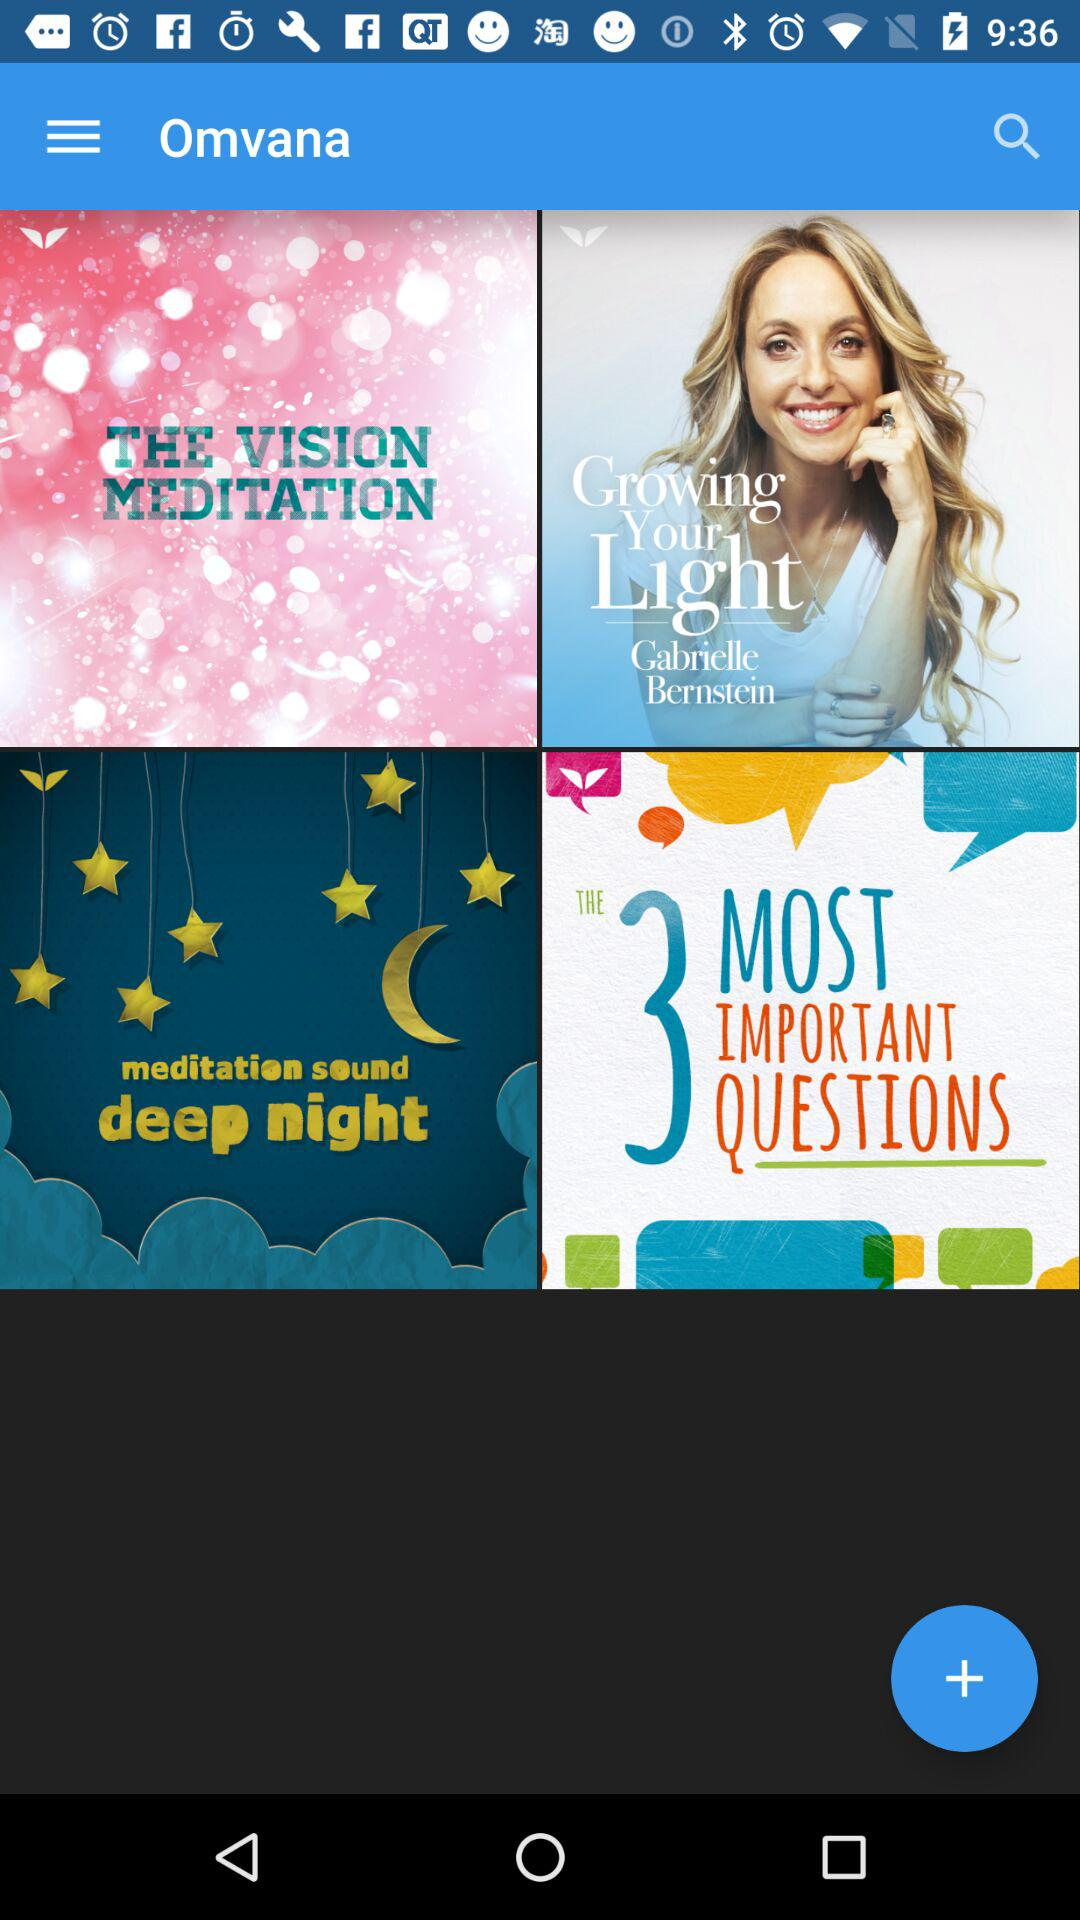What is the application name? The application name is "Omvana". 